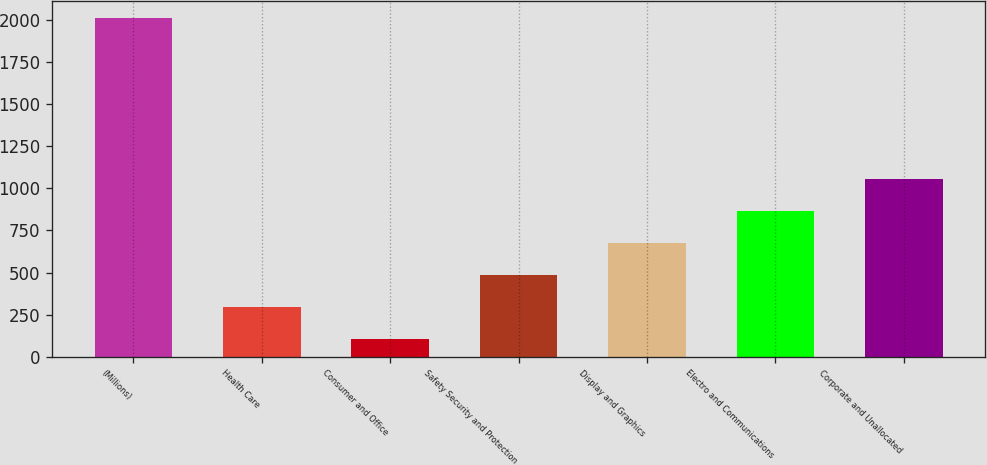Convert chart to OTSL. <chart><loc_0><loc_0><loc_500><loc_500><bar_chart><fcel>(Millions)<fcel>Health Care<fcel>Consumer and Office<fcel>Safety Security and Protection<fcel>Display and Graphics<fcel>Electro and Communications<fcel>Corporate and Unallocated<nl><fcel>2012<fcel>293.9<fcel>103<fcel>484.8<fcel>675.7<fcel>866.6<fcel>1057.5<nl></chart> 